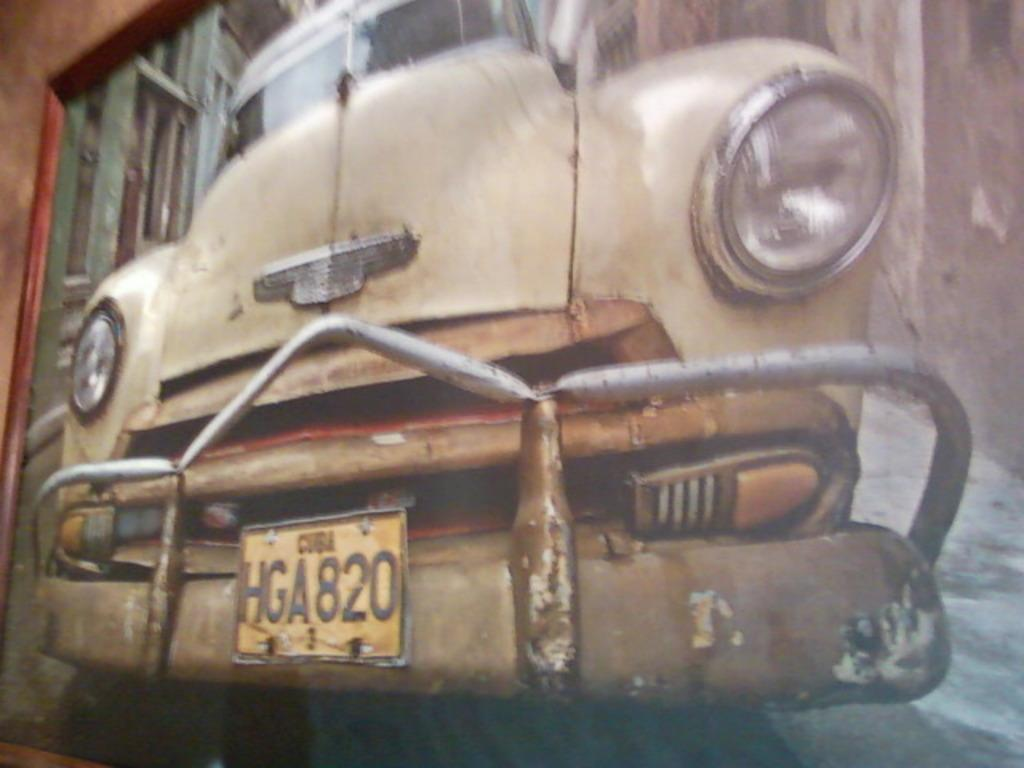What can be seen with a registration plate in the image? There is a vehicle with a registration plate in the image. What type of structure is present in the image? There is a building in the image. What is the other prominent feature in the image? There is a wall in the image. What type of berry is growing on the wall in the image? There are no berries present in the image; it features a vehicle with a registration plate, a building, and a wall. How long is the recess in the building in the image? There is no indication of a recess in the building in the image. 